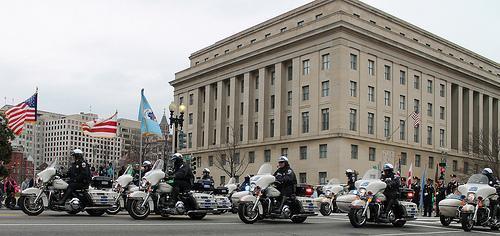How many flags are there?
Give a very brief answer. 3. How many American flags are shown?
Give a very brief answer. 1. 